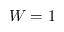Convert formula to latex. <formula><loc_0><loc_0><loc_500><loc_500>W = 1</formula> 